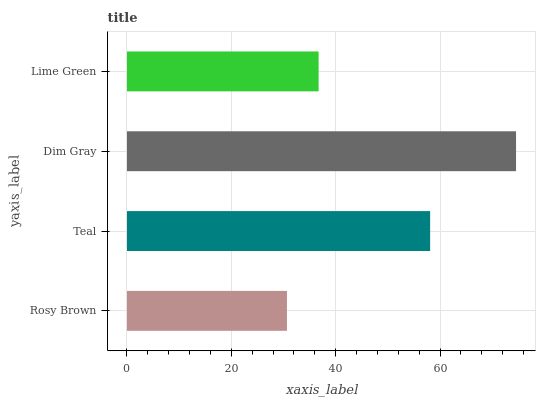Is Rosy Brown the minimum?
Answer yes or no. Yes. Is Dim Gray the maximum?
Answer yes or no. Yes. Is Teal the minimum?
Answer yes or no. No. Is Teal the maximum?
Answer yes or no. No. Is Teal greater than Rosy Brown?
Answer yes or no. Yes. Is Rosy Brown less than Teal?
Answer yes or no. Yes. Is Rosy Brown greater than Teal?
Answer yes or no. No. Is Teal less than Rosy Brown?
Answer yes or no. No. Is Teal the high median?
Answer yes or no. Yes. Is Lime Green the low median?
Answer yes or no. Yes. Is Dim Gray the high median?
Answer yes or no. No. Is Teal the low median?
Answer yes or no. No. 